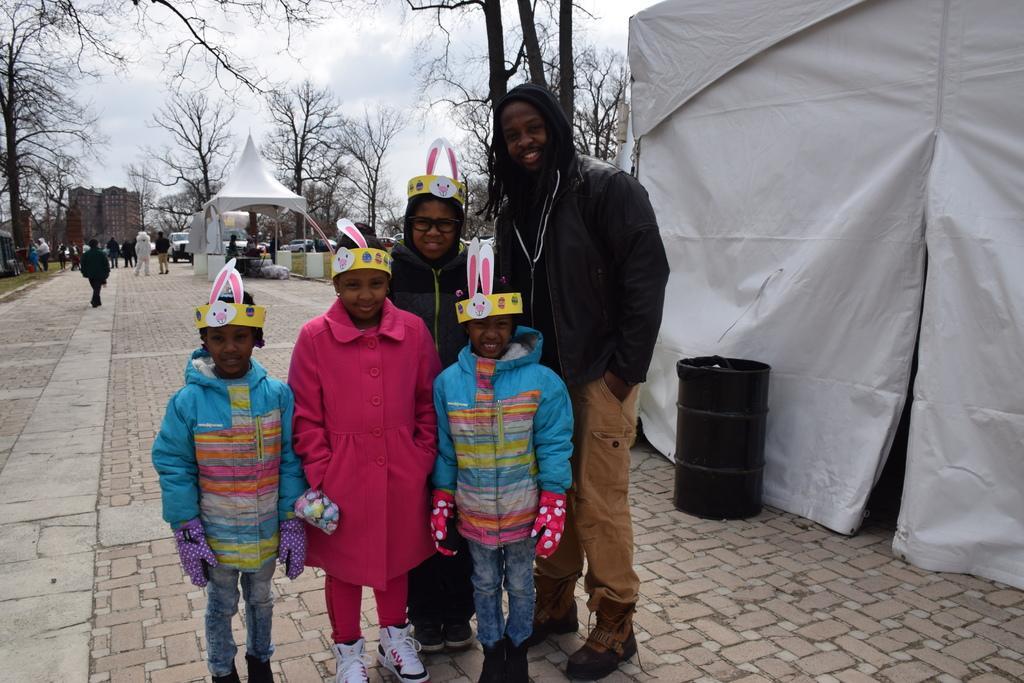In one or two sentences, can you explain what this image depicts? In this picture we can see some small girls wearing a colorful jackets standing in front smiling and giving a pose. Beside there is a African boy wearing a black jacket smiling and standing on the cobbler stones. Behind there is a black drum and white color tint. In the background there is a white color canopy tent and some dry trees. 